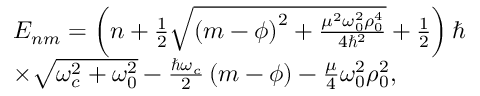<formula> <loc_0><loc_0><loc_500><loc_500>\begin{array} { r l } & { { E } _ { n m } = \left ( n + \frac { 1 } { 2 } \sqrt { \left ( m - \phi \right ) ^ { 2 } + \frac { \mu ^ { 2 } \omega _ { 0 } ^ { 2 } \rho _ { 0 } ^ { 4 } } { 4 \hbar { ^ } { 2 } } } + \frac { 1 } { 2 } \right ) } \\ & { \times \sqrt { \omega _ { c } ^ { 2 } + \omega _ { 0 } ^ { 2 } } - \frac { \hbar { \omega } _ { c } } { 2 } \left ( m - \phi \right ) - \frac { \mu } { 4 } \omega _ { 0 } ^ { 2 } \rho _ { 0 } ^ { 2 } , } \end{array}</formula> 